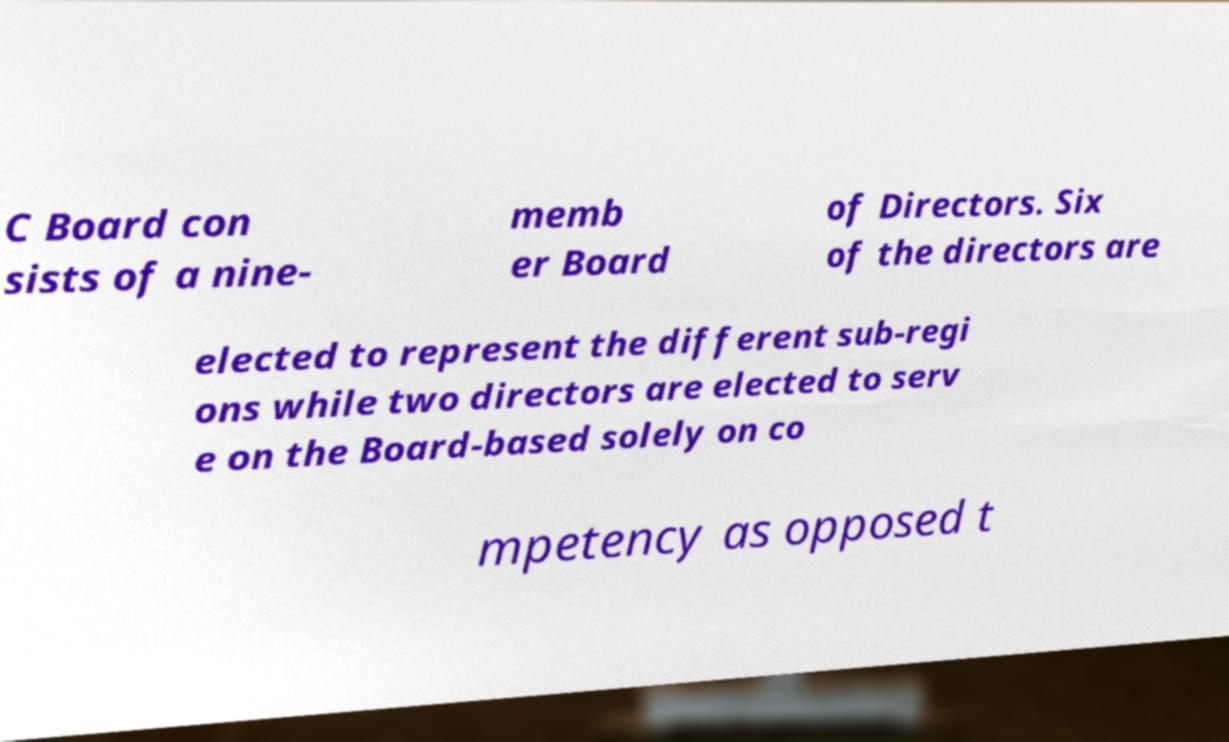Can you accurately transcribe the text from the provided image for me? C Board con sists of a nine- memb er Board of Directors. Six of the directors are elected to represent the different sub-regi ons while two directors are elected to serv e on the Board-based solely on co mpetency as opposed t 